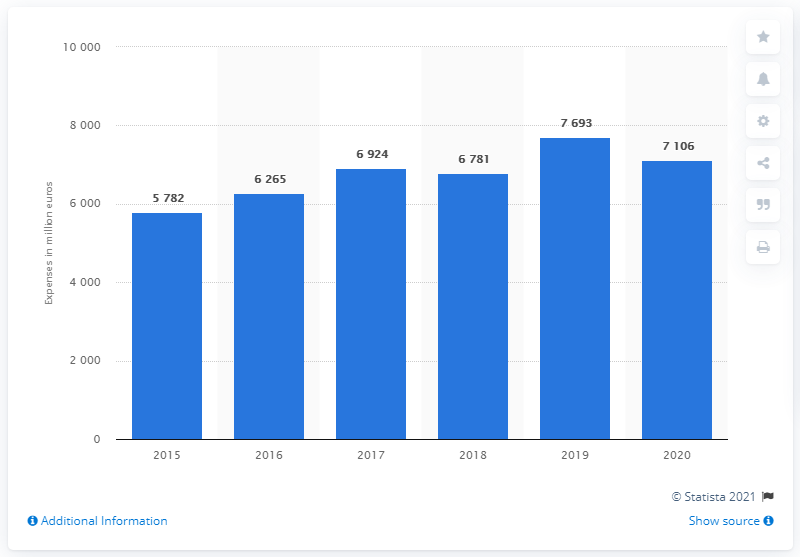Give some essential details in this illustration. SAP's sales and marketing expenses in 2020 were approximately 7,106. 